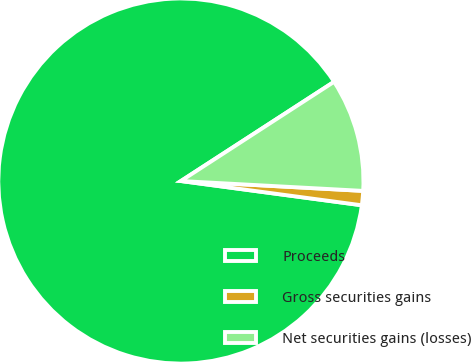Convert chart. <chart><loc_0><loc_0><loc_500><loc_500><pie_chart><fcel>Proceeds<fcel>Gross securities gains<fcel>Net securities gains (losses)<nl><fcel>88.73%<fcel>1.26%<fcel>10.01%<nl></chart> 